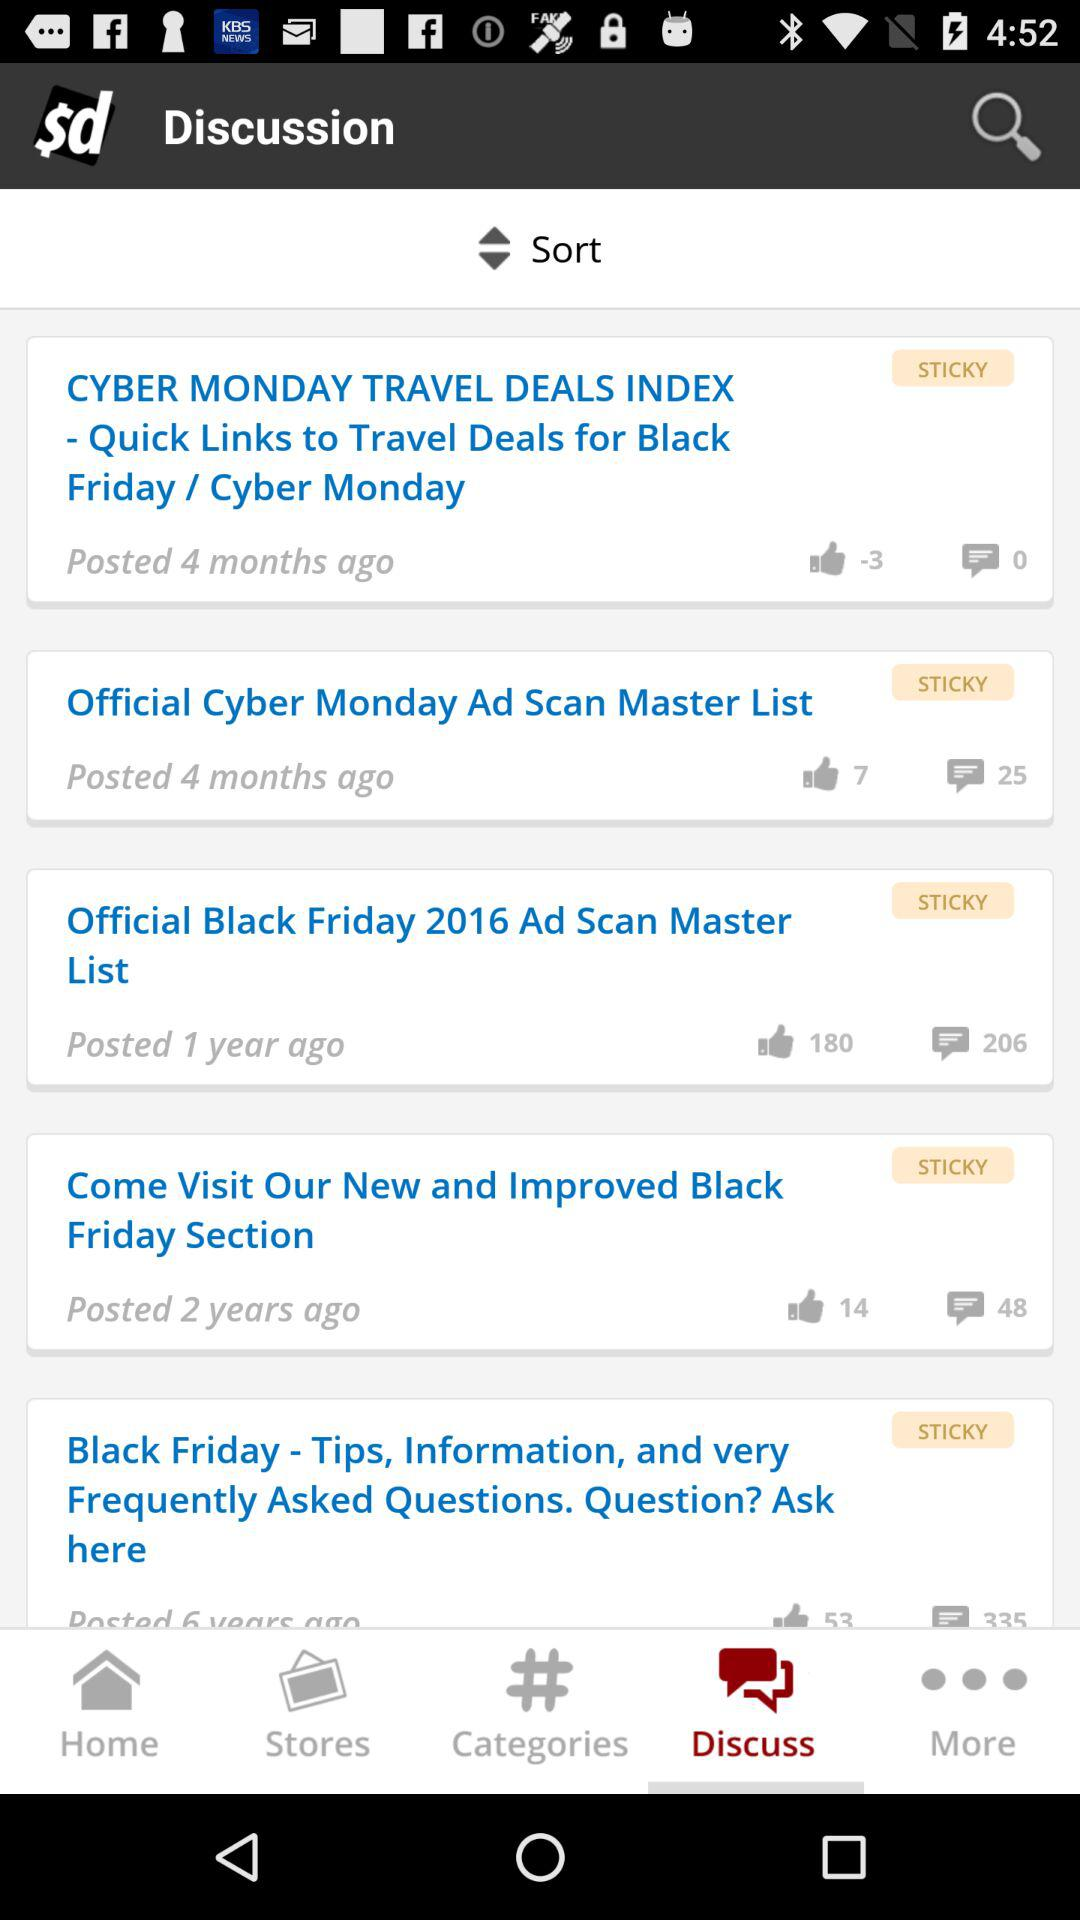How many likes does "Official Cyber Monday Ad Scan Master List" have? "Official Cyber Monday Ad Scan Master List" has 7 likes. 